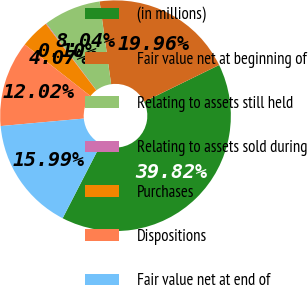Convert chart. <chart><loc_0><loc_0><loc_500><loc_500><pie_chart><fcel>(in millions)<fcel>Fair value net at beginning of<fcel>Relating to assets still held<fcel>Relating to assets sold during<fcel>Purchases<fcel>Dispositions<fcel>Fair value net at end of<nl><fcel>39.82%<fcel>19.96%<fcel>8.04%<fcel>0.1%<fcel>4.07%<fcel>12.02%<fcel>15.99%<nl></chart> 